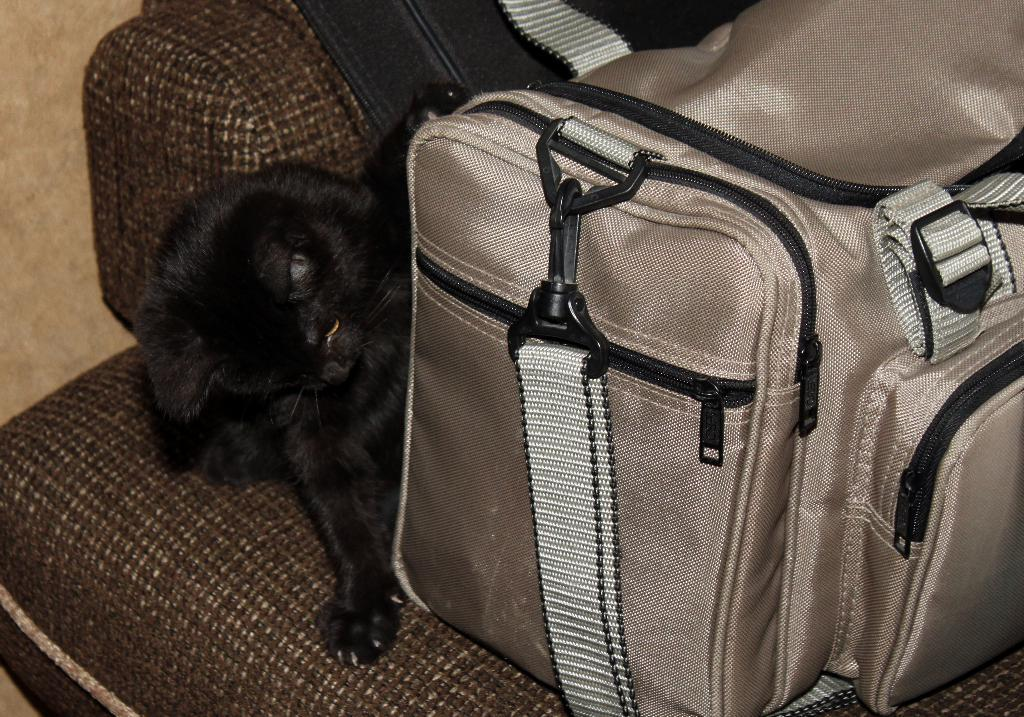What type of furniture is present in the image? There is a sofa in the image. What can be seen on top of the sofa? There is a white luggage with white belts and a brown luggage on the sofa. Is there any living creature present in the image? Yes, there is a black cat between the luggage on the sofa. What class of shade is covering the sofa in the image? There is no shade covering the sofa in the image. What town is depicted in the background of the image? The image does not show a town or any background; it only shows the sofa, luggage, and cat. 